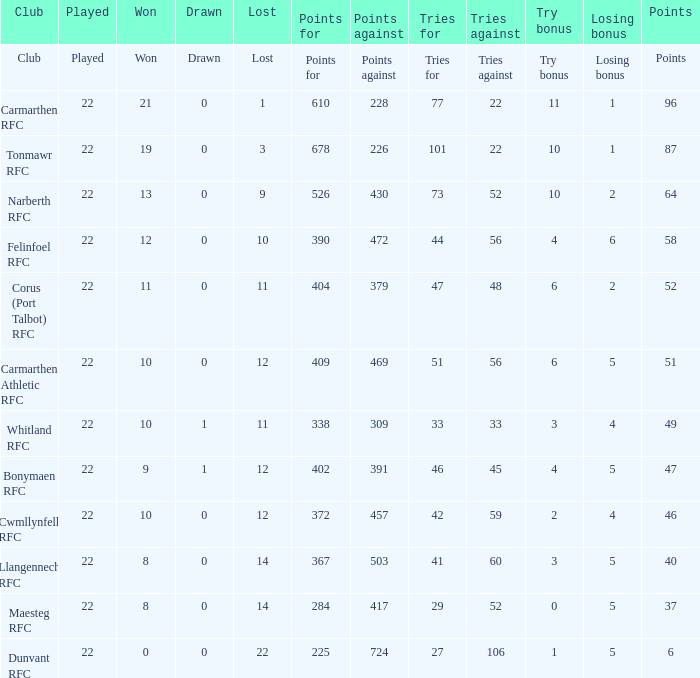Name the try bonus of points against at 430 10.0. 